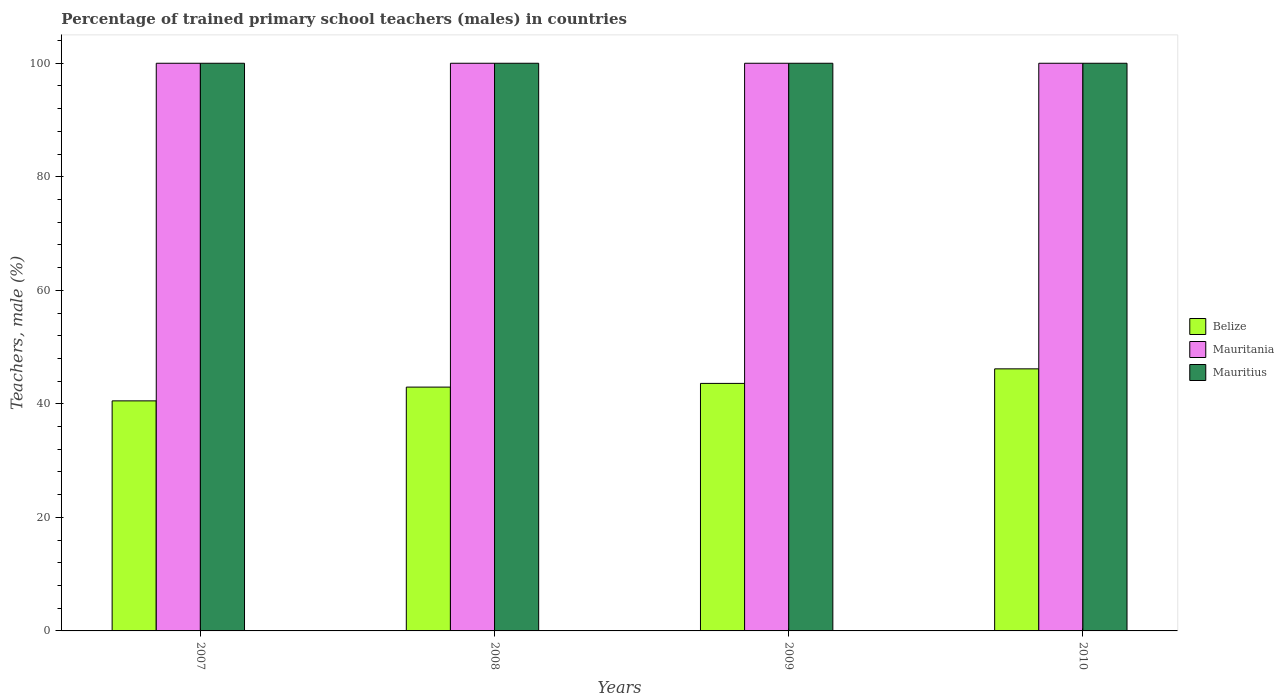How many bars are there on the 3rd tick from the left?
Provide a short and direct response. 3. What is the label of the 2nd group of bars from the left?
Offer a very short reply. 2008. In how many cases, is the number of bars for a given year not equal to the number of legend labels?
Your response must be concise. 0. Across all years, what is the maximum percentage of trained primary school teachers (males) in Belize?
Your response must be concise. 46.17. Across all years, what is the minimum percentage of trained primary school teachers (males) in Mauritania?
Keep it short and to the point. 100. In which year was the percentage of trained primary school teachers (males) in Mauritius minimum?
Offer a very short reply. 2007. What is the total percentage of trained primary school teachers (males) in Mauritania in the graph?
Provide a short and direct response. 400. What is the difference between the percentage of trained primary school teachers (males) in Belize in 2010 and the percentage of trained primary school teachers (males) in Mauritania in 2009?
Provide a short and direct response. -53.83. What is the average percentage of trained primary school teachers (males) in Belize per year?
Your answer should be compact. 43.31. In the year 2008, what is the difference between the percentage of trained primary school teachers (males) in Belize and percentage of trained primary school teachers (males) in Mauritania?
Ensure brevity in your answer.  -57.05. In how many years, is the percentage of trained primary school teachers (males) in Belize greater than 48 %?
Offer a very short reply. 0. What is the difference between the highest and the second highest percentage of trained primary school teachers (males) in Mauritania?
Offer a very short reply. 0. What is the difference between the highest and the lowest percentage of trained primary school teachers (males) in Mauritania?
Your response must be concise. 0. In how many years, is the percentage of trained primary school teachers (males) in Mauritania greater than the average percentage of trained primary school teachers (males) in Mauritania taken over all years?
Ensure brevity in your answer.  0. Is the sum of the percentage of trained primary school teachers (males) in Mauritius in 2008 and 2010 greater than the maximum percentage of trained primary school teachers (males) in Mauritania across all years?
Your response must be concise. Yes. What does the 1st bar from the left in 2007 represents?
Give a very brief answer. Belize. What does the 2nd bar from the right in 2008 represents?
Your response must be concise. Mauritania. How many bars are there?
Provide a short and direct response. 12. Are all the bars in the graph horizontal?
Make the answer very short. No. How many years are there in the graph?
Make the answer very short. 4. Are the values on the major ticks of Y-axis written in scientific E-notation?
Offer a very short reply. No. Does the graph contain grids?
Make the answer very short. No. How many legend labels are there?
Your answer should be compact. 3. What is the title of the graph?
Give a very brief answer. Percentage of trained primary school teachers (males) in countries. What is the label or title of the X-axis?
Give a very brief answer. Years. What is the label or title of the Y-axis?
Ensure brevity in your answer.  Teachers, male (%). What is the Teachers, male (%) of Belize in 2007?
Give a very brief answer. 40.53. What is the Teachers, male (%) in Belize in 2008?
Keep it short and to the point. 42.95. What is the Teachers, male (%) of Mauritania in 2008?
Your response must be concise. 100. What is the Teachers, male (%) in Mauritius in 2008?
Make the answer very short. 100. What is the Teachers, male (%) of Belize in 2009?
Make the answer very short. 43.6. What is the Teachers, male (%) of Mauritius in 2009?
Your answer should be very brief. 100. What is the Teachers, male (%) of Belize in 2010?
Your answer should be compact. 46.17. What is the Teachers, male (%) in Mauritania in 2010?
Offer a very short reply. 100. What is the Teachers, male (%) of Mauritius in 2010?
Provide a succinct answer. 100. Across all years, what is the maximum Teachers, male (%) in Belize?
Keep it short and to the point. 46.17. Across all years, what is the maximum Teachers, male (%) in Mauritania?
Offer a terse response. 100. Across all years, what is the maximum Teachers, male (%) in Mauritius?
Your response must be concise. 100. Across all years, what is the minimum Teachers, male (%) in Belize?
Provide a short and direct response. 40.53. What is the total Teachers, male (%) in Belize in the graph?
Offer a very short reply. 173.25. What is the total Teachers, male (%) in Mauritania in the graph?
Provide a short and direct response. 400. What is the difference between the Teachers, male (%) in Belize in 2007 and that in 2008?
Your response must be concise. -2.42. What is the difference between the Teachers, male (%) in Mauritania in 2007 and that in 2008?
Provide a short and direct response. 0. What is the difference between the Teachers, male (%) of Mauritius in 2007 and that in 2008?
Keep it short and to the point. 0. What is the difference between the Teachers, male (%) of Belize in 2007 and that in 2009?
Offer a terse response. -3.08. What is the difference between the Teachers, male (%) of Belize in 2007 and that in 2010?
Give a very brief answer. -5.64. What is the difference between the Teachers, male (%) of Mauritania in 2007 and that in 2010?
Keep it short and to the point. 0. What is the difference between the Teachers, male (%) in Belize in 2008 and that in 2009?
Offer a terse response. -0.65. What is the difference between the Teachers, male (%) in Mauritania in 2008 and that in 2009?
Provide a succinct answer. 0. What is the difference between the Teachers, male (%) of Belize in 2008 and that in 2010?
Your answer should be compact. -3.21. What is the difference between the Teachers, male (%) in Mauritania in 2008 and that in 2010?
Ensure brevity in your answer.  0. What is the difference between the Teachers, male (%) in Mauritius in 2008 and that in 2010?
Your answer should be compact. 0. What is the difference between the Teachers, male (%) in Belize in 2009 and that in 2010?
Provide a succinct answer. -2.56. What is the difference between the Teachers, male (%) in Mauritius in 2009 and that in 2010?
Your answer should be compact. 0. What is the difference between the Teachers, male (%) of Belize in 2007 and the Teachers, male (%) of Mauritania in 2008?
Your response must be concise. -59.47. What is the difference between the Teachers, male (%) of Belize in 2007 and the Teachers, male (%) of Mauritius in 2008?
Provide a short and direct response. -59.47. What is the difference between the Teachers, male (%) in Mauritania in 2007 and the Teachers, male (%) in Mauritius in 2008?
Provide a succinct answer. 0. What is the difference between the Teachers, male (%) in Belize in 2007 and the Teachers, male (%) in Mauritania in 2009?
Provide a succinct answer. -59.47. What is the difference between the Teachers, male (%) in Belize in 2007 and the Teachers, male (%) in Mauritius in 2009?
Offer a terse response. -59.47. What is the difference between the Teachers, male (%) in Belize in 2007 and the Teachers, male (%) in Mauritania in 2010?
Give a very brief answer. -59.47. What is the difference between the Teachers, male (%) in Belize in 2007 and the Teachers, male (%) in Mauritius in 2010?
Provide a succinct answer. -59.47. What is the difference between the Teachers, male (%) in Mauritania in 2007 and the Teachers, male (%) in Mauritius in 2010?
Provide a succinct answer. 0. What is the difference between the Teachers, male (%) of Belize in 2008 and the Teachers, male (%) of Mauritania in 2009?
Your answer should be compact. -57.05. What is the difference between the Teachers, male (%) of Belize in 2008 and the Teachers, male (%) of Mauritius in 2009?
Ensure brevity in your answer.  -57.05. What is the difference between the Teachers, male (%) in Belize in 2008 and the Teachers, male (%) in Mauritania in 2010?
Make the answer very short. -57.05. What is the difference between the Teachers, male (%) of Belize in 2008 and the Teachers, male (%) of Mauritius in 2010?
Your response must be concise. -57.05. What is the difference between the Teachers, male (%) in Mauritania in 2008 and the Teachers, male (%) in Mauritius in 2010?
Provide a short and direct response. 0. What is the difference between the Teachers, male (%) in Belize in 2009 and the Teachers, male (%) in Mauritania in 2010?
Offer a very short reply. -56.4. What is the difference between the Teachers, male (%) of Belize in 2009 and the Teachers, male (%) of Mauritius in 2010?
Provide a short and direct response. -56.4. What is the difference between the Teachers, male (%) in Mauritania in 2009 and the Teachers, male (%) in Mauritius in 2010?
Provide a succinct answer. 0. What is the average Teachers, male (%) in Belize per year?
Your answer should be very brief. 43.31. In the year 2007, what is the difference between the Teachers, male (%) of Belize and Teachers, male (%) of Mauritania?
Keep it short and to the point. -59.47. In the year 2007, what is the difference between the Teachers, male (%) of Belize and Teachers, male (%) of Mauritius?
Make the answer very short. -59.47. In the year 2008, what is the difference between the Teachers, male (%) in Belize and Teachers, male (%) in Mauritania?
Ensure brevity in your answer.  -57.05. In the year 2008, what is the difference between the Teachers, male (%) of Belize and Teachers, male (%) of Mauritius?
Ensure brevity in your answer.  -57.05. In the year 2009, what is the difference between the Teachers, male (%) in Belize and Teachers, male (%) in Mauritania?
Offer a very short reply. -56.4. In the year 2009, what is the difference between the Teachers, male (%) of Belize and Teachers, male (%) of Mauritius?
Provide a short and direct response. -56.4. In the year 2010, what is the difference between the Teachers, male (%) in Belize and Teachers, male (%) in Mauritania?
Offer a very short reply. -53.83. In the year 2010, what is the difference between the Teachers, male (%) in Belize and Teachers, male (%) in Mauritius?
Offer a terse response. -53.83. In the year 2010, what is the difference between the Teachers, male (%) of Mauritania and Teachers, male (%) of Mauritius?
Your answer should be very brief. 0. What is the ratio of the Teachers, male (%) of Belize in 2007 to that in 2008?
Offer a very short reply. 0.94. What is the ratio of the Teachers, male (%) of Mauritania in 2007 to that in 2008?
Keep it short and to the point. 1. What is the ratio of the Teachers, male (%) in Belize in 2007 to that in 2009?
Offer a terse response. 0.93. What is the ratio of the Teachers, male (%) in Mauritius in 2007 to that in 2009?
Provide a succinct answer. 1. What is the ratio of the Teachers, male (%) in Belize in 2007 to that in 2010?
Keep it short and to the point. 0.88. What is the ratio of the Teachers, male (%) in Mauritania in 2007 to that in 2010?
Offer a terse response. 1. What is the ratio of the Teachers, male (%) of Mauritius in 2007 to that in 2010?
Your answer should be compact. 1. What is the ratio of the Teachers, male (%) of Mauritius in 2008 to that in 2009?
Offer a terse response. 1. What is the ratio of the Teachers, male (%) of Belize in 2008 to that in 2010?
Offer a terse response. 0.93. What is the ratio of the Teachers, male (%) of Mauritius in 2008 to that in 2010?
Provide a succinct answer. 1. What is the ratio of the Teachers, male (%) in Belize in 2009 to that in 2010?
Provide a short and direct response. 0.94. What is the ratio of the Teachers, male (%) in Mauritania in 2009 to that in 2010?
Your answer should be very brief. 1. What is the difference between the highest and the second highest Teachers, male (%) of Belize?
Ensure brevity in your answer.  2.56. What is the difference between the highest and the second highest Teachers, male (%) of Mauritius?
Provide a short and direct response. 0. What is the difference between the highest and the lowest Teachers, male (%) of Belize?
Offer a very short reply. 5.64. 